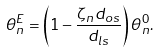Convert formula to latex. <formula><loc_0><loc_0><loc_500><loc_500>\theta ^ { E } _ { n } = \left ( 1 - \frac { \zeta _ { n } d _ { o s } } { d _ { l s } } \right ) \theta ^ { 0 } _ { n } .</formula> 